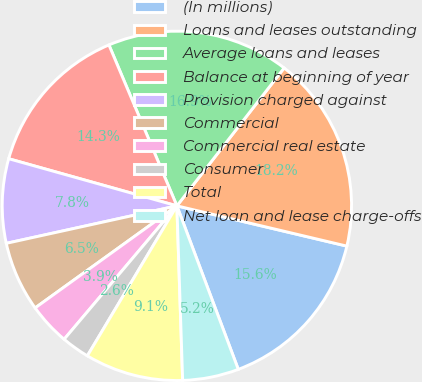Convert chart. <chart><loc_0><loc_0><loc_500><loc_500><pie_chart><fcel>(In millions)<fcel>Loans and leases outstanding<fcel>Average loans and leases<fcel>Balance at beginning of year<fcel>Provision charged against<fcel>Commercial<fcel>Commercial real estate<fcel>Consumer<fcel>Total<fcel>Net loan and lease charge-offs<nl><fcel>15.58%<fcel>18.18%<fcel>16.88%<fcel>14.29%<fcel>7.79%<fcel>6.49%<fcel>3.9%<fcel>2.6%<fcel>9.09%<fcel>5.19%<nl></chart> 